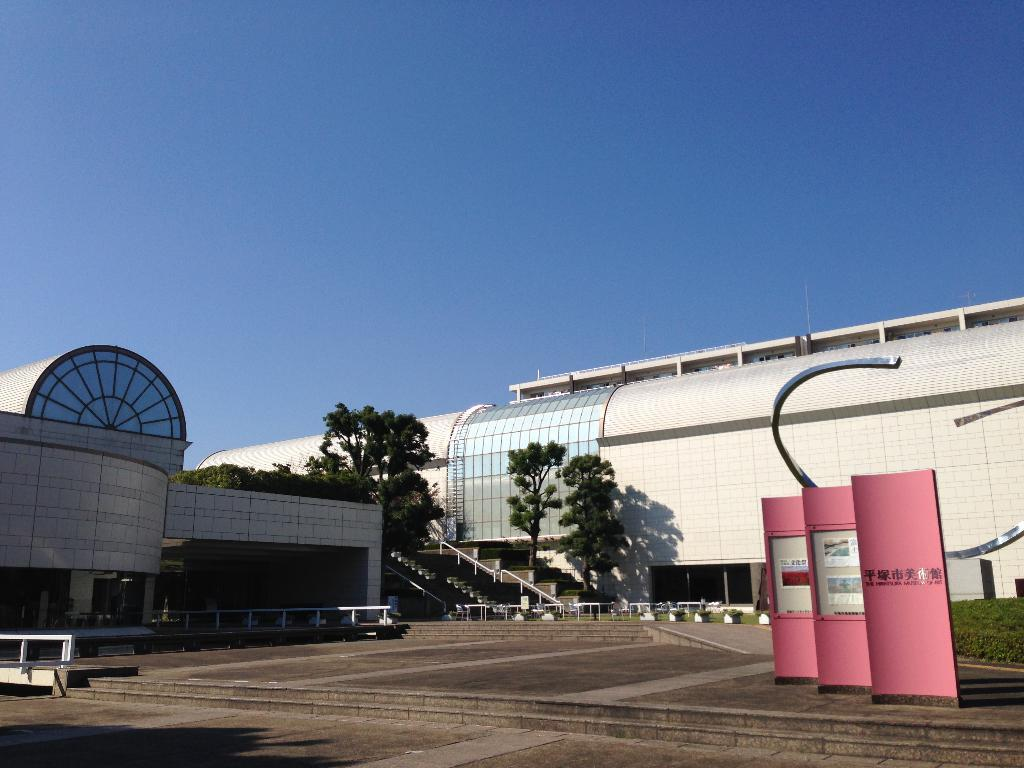What type of structures can be seen in the image? There are buildings in the image. What other natural elements are present in the image? There are trees in the image. Are there any architectural features that can be observed? Yes, there are stairs visible in the image. What is visible in the background of the image? The sky is visible in the background of the image. What type of powder is being used to drive the turkey in the image? There is no powder or turkey present in the image. 